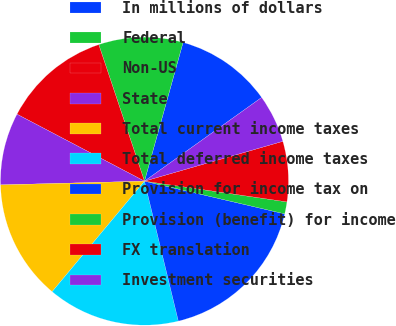Convert chart to OTSL. <chart><loc_0><loc_0><loc_500><loc_500><pie_chart><fcel>In millions of dollars<fcel>Federal<fcel>Non-US<fcel>State<fcel>Total current income taxes<fcel>Total deferred income taxes<fcel>Provision for income tax on<fcel>Provision (benefit) for income<fcel>FX translation<fcel>Investment securities<nl><fcel>10.81%<fcel>9.46%<fcel>12.16%<fcel>8.11%<fcel>13.51%<fcel>14.86%<fcel>17.57%<fcel>1.35%<fcel>6.76%<fcel>5.41%<nl></chart> 